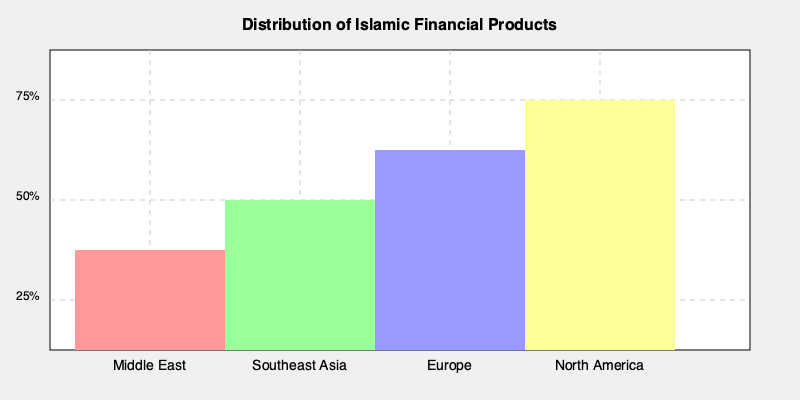Based on the graph showing the distribution of Islamic financial products across different regions, which region has the highest adoption rate? To determine which region has the highest adoption rate of Islamic financial products, we need to compare the heights of the bars for each region:

1. Middle East: The bar extends from approximately 50% to 75% on the y-axis, indicating about 25% adoption.
2. Southeast Asia: The bar extends from about 37.5% to 75% on the y-axis, indicating roughly 37.5% adoption.
3. Europe: The bar extends from about 25% to 75% on the y-axis, indicating approximately 50% adoption.
4. North America: The bar extends from about 12.5% to 75% on the y-axis, indicating roughly 62.5% adoption.

By comparing these values, we can see that North America has the tallest bar, representing the highest adoption rate of Islamic financial products among the regions shown.
Answer: North America 